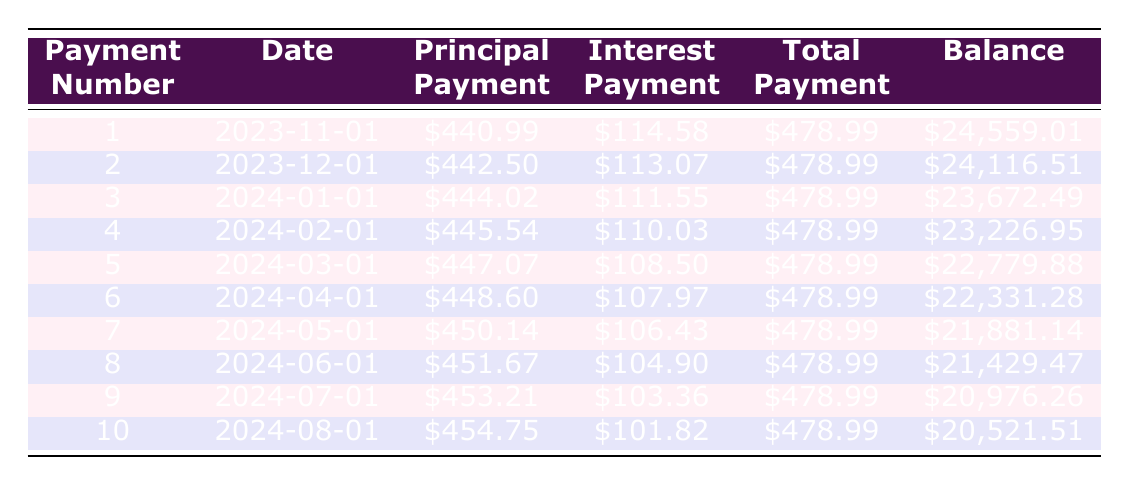What is the total payment amount for the first payment? The total payment amount for the first payment is listed in the "Total Payment" column for payment number 1. It is $478.99.
Answer: 478.99 What is the remaining balance after the second payment? The remaining balance after the second payment is found in the "Remaining Balance" column for payment number 2. It is $24,116.51.
Answer: 24116.51 How much was the total principal paid after the first three payments? To find the total principal paid after the first three payments, we look at the "Principal Payment" column for payments 1, 2, and 3: $440.99 + $442.50 + $444.02 = $1327.51.
Answer: 1327.51 Was the interest payment for the fourth payment greater than $110? The interest payment for the fourth payment is $110.03, which is greater than $110.
Answer: Yes What is the difference in remaining balance between the first and fifth payments? The remaining balance of the first payment is $24,559.01, and the fifth payment is $22,779.88. The difference is $24,559.01 - $22,779.88 = $1,779.13.
Answer: 1779.13 What is the average principal payment for the first ten payments? To find the average principal payment for the first ten payments, sum the principal payments for each of the ten payments, which adds up to $4,449.65. Dividing that by 10 gives an average of $444.97.
Answer: 444.97 What was the interest amount for payment number 5? The interest amount for payment number 5 is obtained from the "Interest Payment" column for payment number 5, which is $108.50.
Answer: 108.50 Do the payments decrease in the interest amount as more payments are made? Observing the "Interest Payment" column, payments from number 1 to 10 show a decreasing trend, confirming that the interest payment decreases with each payment.
Answer: Yes How much total payment is made in the first two payments combined? The total payment for the first payment is $478.99 and for the second payment is also $478.99. Adding these gives $478.99 + $478.99 = $957.98.
Answer: 957.98 